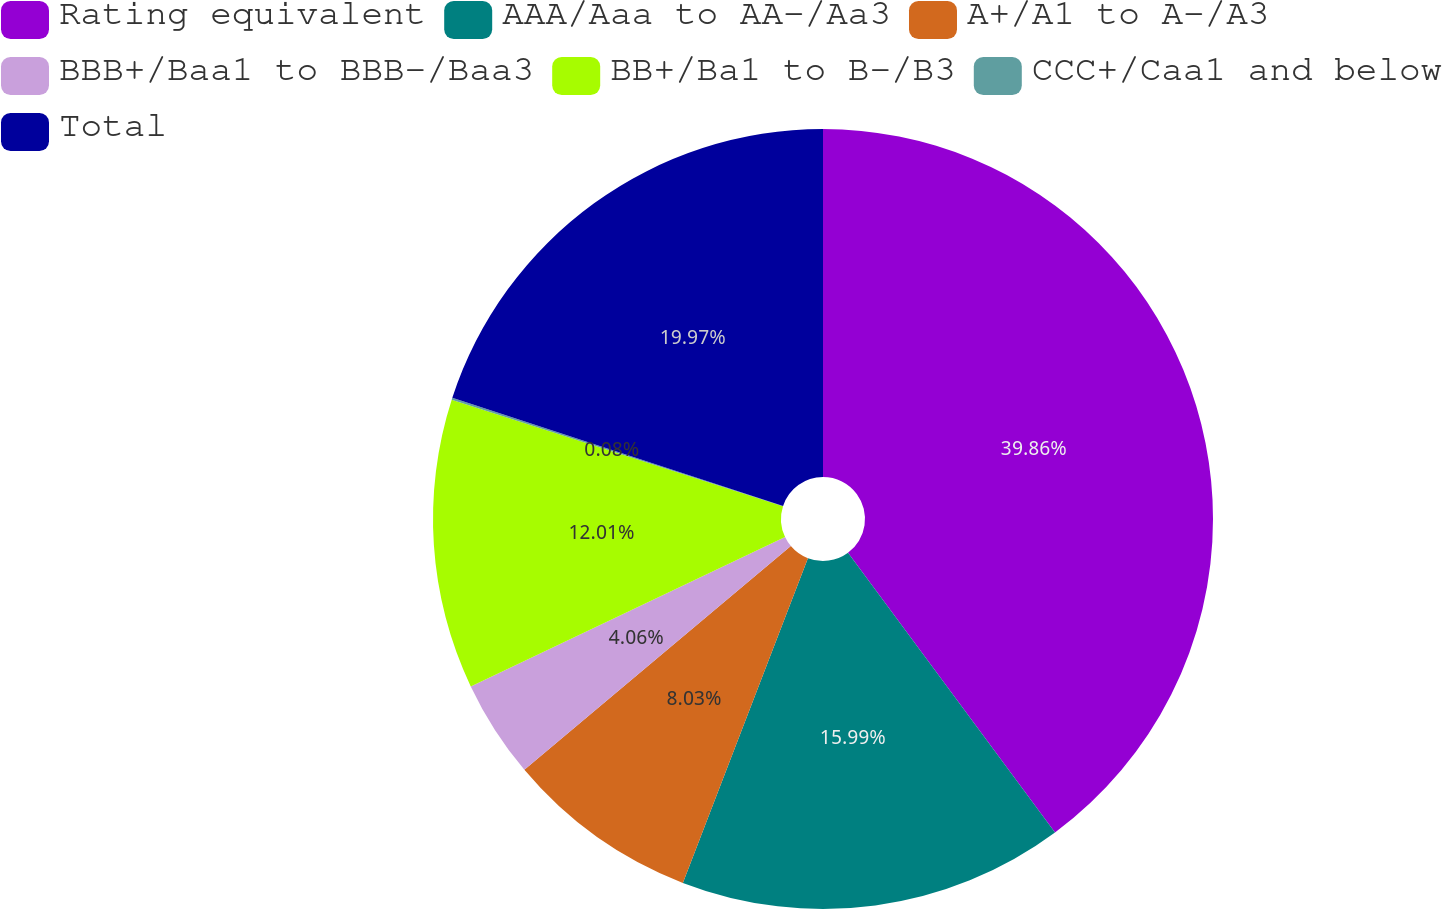Convert chart. <chart><loc_0><loc_0><loc_500><loc_500><pie_chart><fcel>Rating equivalent<fcel>AAA/Aaa to AA-/Aa3<fcel>A+/A1 to A-/A3<fcel>BBB+/Baa1 to BBB-/Baa3<fcel>BB+/Ba1 to B-/B3<fcel>CCC+/Caa1 and below<fcel>Total<nl><fcel>39.86%<fcel>15.99%<fcel>8.03%<fcel>4.06%<fcel>12.01%<fcel>0.08%<fcel>19.97%<nl></chart> 